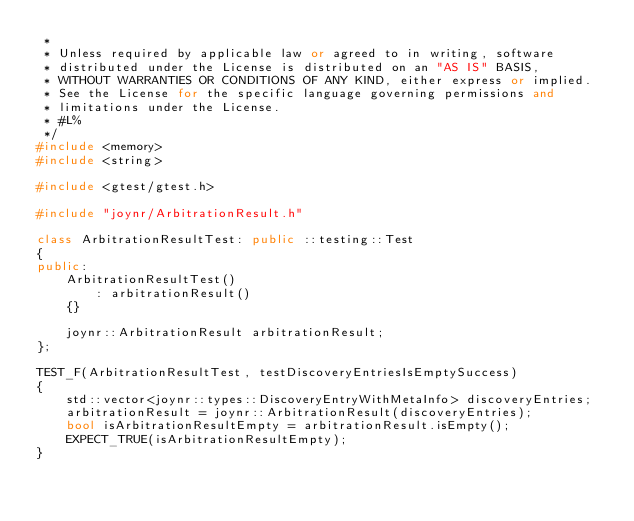Convert code to text. <code><loc_0><loc_0><loc_500><loc_500><_C++_> *
 * Unless required by applicable law or agreed to in writing, software
 * distributed under the License is distributed on an "AS IS" BASIS,
 * WITHOUT WARRANTIES OR CONDITIONS OF ANY KIND, either express or implied.
 * See the License for the specific language governing permissions and
 * limitations under the License.
 * #L%
 */
#include <memory>
#include <string>

#include <gtest/gtest.h>

#include "joynr/ArbitrationResult.h"

class ArbitrationResultTest: public ::testing::Test
{
public:
    ArbitrationResultTest()
        : arbitrationResult()
    {}

    joynr::ArbitrationResult arbitrationResult;
};

TEST_F(ArbitrationResultTest, testDiscoveryEntriesIsEmptySuccess)
{
    std::vector<joynr::types::DiscoveryEntryWithMetaInfo> discoveryEntries;
    arbitrationResult = joynr::ArbitrationResult(discoveryEntries);
    bool isArbitrationResultEmpty = arbitrationResult.isEmpty();
    EXPECT_TRUE(isArbitrationResultEmpty);
}
</code> 